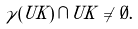<formula> <loc_0><loc_0><loc_500><loc_500>\gamma ( U K ) \, \cap \, U K \, \neq \, \emptyset .</formula> 